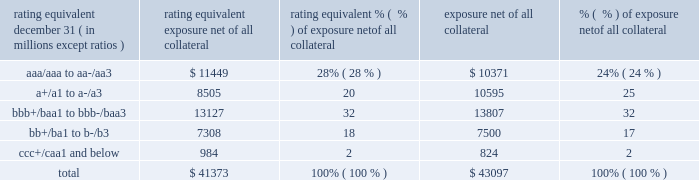Jpmorgan chase & co./2016 annual report 103 risk in the derivatives portfolio .
In addition , the firm 2019s risk management process takes into consideration the potential impact of wrong-way risk , which is broadly defined as the potential for increased correlation between the firm 2019s exposure to a counterparty ( avg ) and the counterparty 2019s credit quality .
Many factors may influence the nature and magnitude of these correlations over time .
To the extent that these correlations are identified , the firm may adjust the cva associated with that counterparty 2019s avg .
The firm risk manages exposure to changes in cva by entering into credit derivative transactions , as well as interest rate , foreign exchange , equity and commodity derivative transactions .
The accompanying graph shows exposure profiles to the firm 2019s current derivatives portfolio over the next 10 years as calculated by the peak , dre and avg metrics .
The three measures generally show that exposure will decline after the first year , if no new trades are added to the portfolio .
Exposure profile of derivatives measures december 31 , 2016 ( in billions ) the table summarizes the ratings profile by derivative counterparty of the firm 2019s derivative receivables , including credit derivatives , net of all collateral , at the dates indicated .
The ratings scale is based on the firm 2019s internal ratings , which generally correspond to the ratings as defined by s&p and moody 2019s .
Ratings profile of derivative receivables rating equivalent 2016 2015 ( a ) december 31 , ( in millions , except ratios ) exposure net of all collateral % (  % ) of exposure net of all collateral exposure net of all collateral % (  % ) of exposure net of all collateral .
( a ) prior period amounts have been revised to conform with the current period presentation .
As previously noted , the firm uses collateral agreements to mitigate counterparty credit risk .
The percentage of the firm 2019s derivatives transactions subject to collateral agreements 2014 excluding foreign exchange spot trades , which are not typically covered by collateral agreements due to their short maturity 2014 was 90% ( 90 % ) as of december 31 , 2016 , largely unchanged compared with 87% ( 87 % ) as of december 31 , 2015 .
Credit derivatives the firm uses credit derivatives for two primary purposes : first , in its capacity as a market-maker , and second , as an end-user to manage the firm 2019s own credit risk associated with various exposures .
For a detailed description of credit derivatives , see credit derivatives in note 6 .
Credit portfolio management activities included in the firm 2019s end-user activities are credit derivatives used to mitigate the credit risk associated with traditional lending activities ( loans and unfunded commitments ) and derivatives counterparty exposure in the firm 2019s wholesale businesses ( collectively , 201ccredit portfolio management 201d activities ) .
Information on credit portfolio management activities is provided in the table below .
For further information on derivatives used in credit portfolio management activities , see credit derivatives in note 6 .
The firm also uses credit derivatives as an end-user to manage other exposures , including credit risk arising from certain securities held in the firm 2019s market-making businesses .
These credit derivatives are not included in credit portfolio management activities ; for further information on these credit derivatives as well as credit derivatives used in the firm 2019s capacity as a market-maker in credit derivatives , see credit derivatives in note 6. .
In 2016 what was the ratio of the aaa/aaa to aa-/aa3 to the a+/a1 to a-/a3? 
Computations: (11449 / 8505)
Answer: 1.34615. Jpmorgan chase & co./2016 annual report 103 risk in the derivatives portfolio .
In addition , the firm 2019s risk management process takes into consideration the potential impact of wrong-way risk , which is broadly defined as the potential for increased correlation between the firm 2019s exposure to a counterparty ( avg ) and the counterparty 2019s credit quality .
Many factors may influence the nature and magnitude of these correlations over time .
To the extent that these correlations are identified , the firm may adjust the cva associated with that counterparty 2019s avg .
The firm risk manages exposure to changes in cva by entering into credit derivative transactions , as well as interest rate , foreign exchange , equity and commodity derivative transactions .
The accompanying graph shows exposure profiles to the firm 2019s current derivatives portfolio over the next 10 years as calculated by the peak , dre and avg metrics .
The three measures generally show that exposure will decline after the first year , if no new trades are added to the portfolio .
Exposure profile of derivatives measures december 31 , 2016 ( in billions ) the table summarizes the ratings profile by derivative counterparty of the firm 2019s derivative receivables , including credit derivatives , net of all collateral , at the dates indicated .
The ratings scale is based on the firm 2019s internal ratings , which generally correspond to the ratings as defined by s&p and moody 2019s .
Ratings profile of derivative receivables rating equivalent 2016 2015 ( a ) december 31 , ( in millions , except ratios ) exposure net of all collateral % (  % ) of exposure net of all collateral exposure net of all collateral % (  % ) of exposure net of all collateral .
( a ) prior period amounts have been revised to conform with the current period presentation .
As previously noted , the firm uses collateral agreements to mitigate counterparty credit risk .
The percentage of the firm 2019s derivatives transactions subject to collateral agreements 2014 excluding foreign exchange spot trades , which are not typically covered by collateral agreements due to their short maturity 2014 was 90% ( 90 % ) as of december 31 , 2016 , largely unchanged compared with 87% ( 87 % ) as of december 31 , 2015 .
Credit derivatives the firm uses credit derivatives for two primary purposes : first , in its capacity as a market-maker , and second , as an end-user to manage the firm 2019s own credit risk associated with various exposures .
For a detailed description of credit derivatives , see credit derivatives in note 6 .
Credit portfolio management activities included in the firm 2019s end-user activities are credit derivatives used to mitigate the credit risk associated with traditional lending activities ( loans and unfunded commitments ) and derivatives counterparty exposure in the firm 2019s wholesale businesses ( collectively , 201ccredit portfolio management 201d activities ) .
Information on credit portfolio management activities is provided in the table below .
For further information on derivatives used in credit portfolio management activities , see credit derivatives in note 6 .
The firm also uses credit derivatives as an end-user to manage other exposures , including credit risk arising from certain securities held in the firm 2019s market-making businesses .
These credit derivatives are not included in credit portfolio management activities ; for further information on these credit derivatives as well as credit derivatives used in the firm 2019s capacity as a market-maker in credit derivatives , see credit derivatives in note 6. .
What percentage of the 2016 ratings profile of derivative receivables had a rating equivalent for junk ratings? 
Rationale: junk is below bbb+/baa1 to bbb-/baa3
Computations: (18 + 2)
Answer: 20.0. 